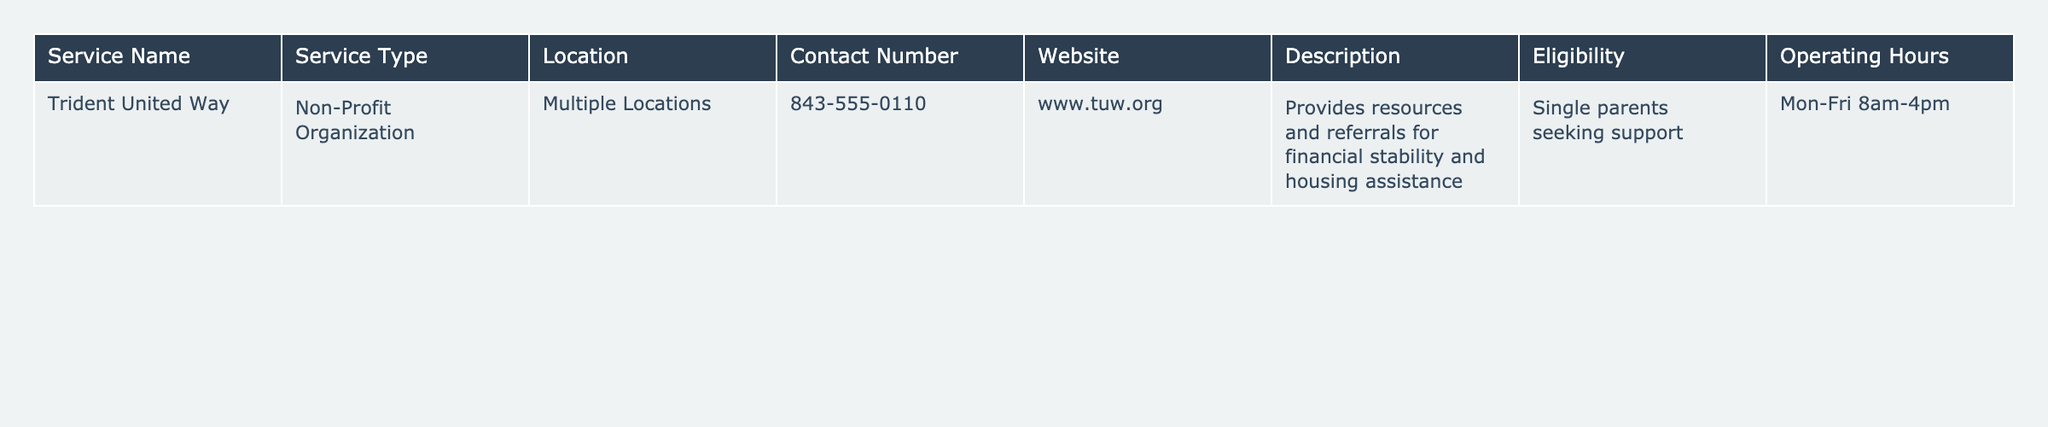What is the name of the service provided? The table lists the service name under the "Service Name" column, which is "Trident United Way."
Answer: Trident United Way What type of organization is Trident United Way? The "Service Type" column indicates that it is a "Non-Profit Organization."
Answer: Non-Profit Organization Where is Trident United Way located? The "Location" column shows that this service has "Multiple Locations."
Answer: Multiple Locations What is the contact number for Trident United Way? The contact number is provided in the "Contact Number" column as "843-555-0110."
Answer: 843-555-0110 Is there a website listed for Trident United Way? The "Website" column includes "www.tuw.org," indicating there is a website.
Answer: Yes What services does Trident United Way provide? The "Description" column states it provides "resources and referrals for financial stability and housing assistance."
Answer: Resources and referrals for financial stability and housing assistance Who is eligible for Trident United Way services? The "Eligibility" section mentions that services are for "Single parents seeking support."
Answer: Single parents seeking support What are the operating hours for Trident United Way? According to the "Operating Hours" column, the operating hours are "Mon-Fri 8am-4pm."
Answer: Mon-Fri 8am-4pm Are there any other types of services available besides non-profit organizations in this table? There is only one service provided in the table, which is Trident United Way, categorized as a non-profit.
Answer: No What is the primary goal of Trident United Way based on the description? The description indicates that the goal is to help with "financial stability and housing assistance" for single parents.
Answer: To help with financial stability and housing assistance If a single parent needs help on a Saturday, can they contact Trident United Way? The operating hours indicate services are only available Monday to Friday.
Answer: No 